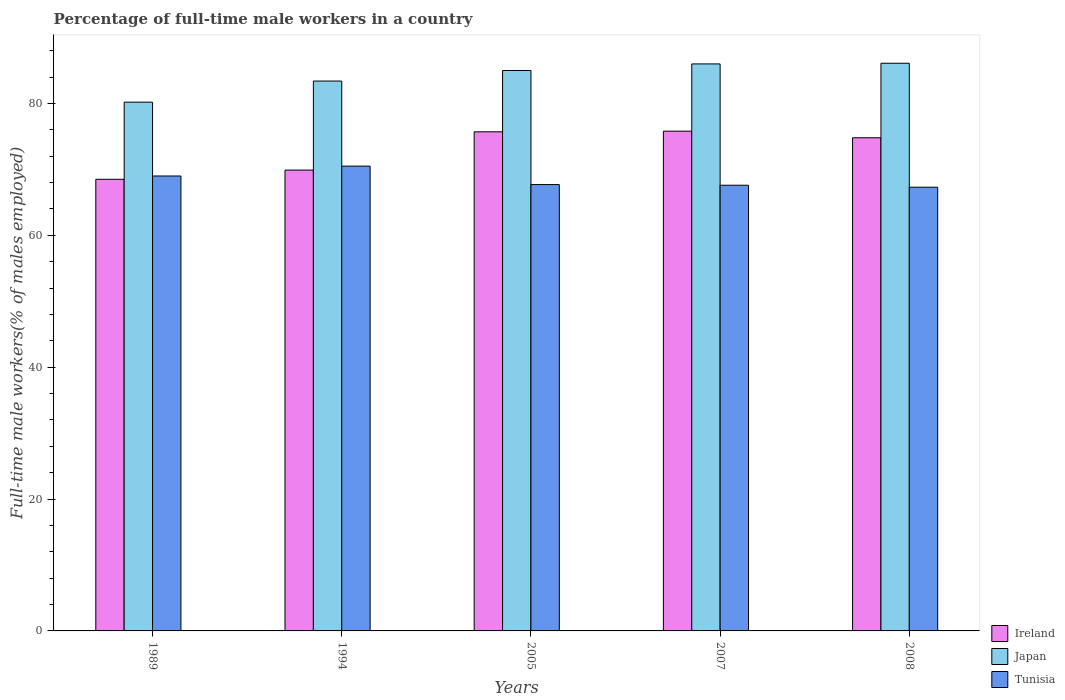Are the number of bars per tick equal to the number of legend labels?
Offer a terse response. Yes. Are the number of bars on each tick of the X-axis equal?
Give a very brief answer. Yes. How many bars are there on the 2nd tick from the left?
Your answer should be very brief. 3. What is the label of the 2nd group of bars from the left?
Offer a terse response. 1994. What is the percentage of full-time male workers in Tunisia in 2005?
Offer a very short reply. 67.7. Across all years, what is the maximum percentage of full-time male workers in Japan?
Give a very brief answer. 86.1. Across all years, what is the minimum percentage of full-time male workers in Tunisia?
Make the answer very short. 67.3. In which year was the percentage of full-time male workers in Japan minimum?
Make the answer very short. 1989. What is the total percentage of full-time male workers in Tunisia in the graph?
Provide a short and direct response. 342.1. What is the difference between the percentage of full-time male workers in Tunisia in 1989 and that in 2008?
Offer a very short reply. 1.7. What is the difference between the percentage of full-time male workers in Tunisia in 2008 and the percentage of full-time male workers in Japan in 1989?
Provide a succinct answer. -12.9. What is the average percentage of full-time male workers in Ireland per year?
Provide a short and direct response. 72.94. In the year 1989, what is the difference between the percentage of full-time male workers in Tunisia and percentage of full-time male workers in Japan?
Offer a very short reply. -11.2. What is the ratio of the percentage of full-time male workers in Tunisia in 1989 to that in 2007?
Offer a very short reply. 1.02. Is the difference between the percentage of full-time male workers in Tunisia in 1989 and 1994 greater than the difference between the percentage of full-time male workers in Japan in 1989 and 1994?
Make the answer very short. Yes. What is the difference between the highest and the lowest percentage of full-time male workers in Japan?
Ensure brevity in your answer.  5.9. In how many years, is the percentage of full-time male workers in Japan greater than the average percentage of full-time male workers in Japan taken over all years?
Ensure brevity in your answer.  3. What does the 3rd bar from the left in 2005 represents?
Your answer should be compact. Tunisia. What does the 2nd bar from the right in 1989 represents?
Provide a succinct answer. Japan. Is it the case that in every year, the sum of the percentage of full-time male workers in Ireland and percentage of full-time male workers in Japan is greater than the percentage of full-time male workers in Tunisia?
Make the answer very short. Yes. How many bars are there?
Provide a succinct answer. 15. Are all the bars in the graph horizontal?
Your answer should be very brief. No. How many years are there in the graph?
Provide a succinct answer. 5. What is the difference between two consecutive major ticks on the Y-axis?
Offer a terse response. 20. Are the values on the major ticks of Y-axis written in scientific E-notation?
Your answer should be compact. No. Does the graph contain grids?
Your answer should be compact. No. What is the title of the graph?
Your answer should be very brief. Percentage of full-time male workers in a country. What is the label or title of the Y-axis?
Offer a very short reply. Full-time male workers(% of males employed). What is the Full-time male workers(% of males employed) in Ireland in 1989?
Keep it short and to the point. 68.5. What is the Full-time male workers(% of males employed) in Japan in 1989?
Provide a succinct answer. 80.2. What is the Full-time male workers(% of males employed) in Tunisia in 1989?
Ensure brevity in your answer.  69. What is the Full-time male workers(% of males employed) of Ireland in 1994?
Offer a very short reply. 69.9. What is the Full-time male workers(% of males employed) of Japan in 1994?
Keep it short and to the point. 83.4. What is the Full-time male workers(% of males employed) in Tunisia in 1994?
Keep it short and to the point. 70.5. What is the Full-time male workers(% of males employed) of Ireland in 2005?
Provide a short and direct response. 75.7. What is the Full-time male workers(% of males employed) in Tunisia in 2005?
Your answer should be very brief. 67.7. What is the Full-time male workers(% of males employed) of Ireland in 2007?
Offer a very short reply. 75.8. What is the Full-time male workers(% of males employed) in Tunisia in 2007?
Offer a terse response. 67.6. What is the Full-time male workers(% of males employed) in Ireland in 2008?
Provide a succinct answer. 74.8. What is the Full-time male workers(% of males employed) of Japan in 2008?
Provide a short and direct response. 86.1. What is the Full-time male workers(% of males employed) of Tunisia in 2008?
Keep it short and to the point. 67.3. Across all years, what is the maximum Full-time male workers(% of males employed) in Ireland?
Provide a succinct answer. 75.8. Across all years, what is the maximum Full-time male workers(% of males employed) in Japan?
Keep it short and to the point. 86.1. Across all years, what is the maximum Full-time male workers(% of males employed) of Tunisia?
Ensure brevity in your answer.  70.5. Across all years, what is the minimum Full-time male workers(% of males employed) in Ireland?
Provide a short and direct response. 68.5. Across all years, what is the minimum Full-time male workers(% of males employed) of Japan?
Make the answer very short. 80.2. Across all years, what is the minimum Full-time male workers(% of males employed) of Tunisia?
Keep it short and to the point. 67.3. What is the total Full-time male workers(% of males employed) of Ireland in the graph?
Provide a short and direct response. 364.7. What is the total Full-time male workers(% of males employed) in Japan in the graph?
Give a very brief answer. 420.7. What is the total Full-time male workers(% of males employed) in Tunisia in the graph?
Ensure brevity in your answer.  342.1. What is the difference between the Full-time male workers(% of males employed) in Tunisia in 1989 and that in 2005?
Offer a terse response. 1.3. What is the difference between the Full-time male workers(% of males employed) in Japan in 1989 and that in 2007?
Provide a succinct answer. -5.8. What is the difference between the Full-time male workers(% of males employed) of Japan in 1989 and that in 2008?
Your answer should be very brief. -5.9. What is the difference between the Full-time male workers(% of males employed) in Tunisia in 1989 and that in 2008?
Your response must be concise. 1.7. What is the difference between the Full-time male workers(% of males employed) of Tunisia in 1994 and that in 2005?
Ensure brevity in your answer.  2.8. What is the difference between the Full-time male workers(% of males employed) in Ireland in 1994 and that in 2007?
Your response must be concise. -5.9. What is the difference between the Full-time male workers(% of males employed) of Ireland in 1994 and that in 2008?
Offer a terse response. -4.9. What is the difference between the Full-time male workers(% of males employed) of Japan in 1994 and that in 2008?
Ensure brevity in your answer.  -2.7. What is the difference between the Full-time male workers(% of males employed) in Ireland in 2005 and that in 2007?
Offer a terse response. -0.1. What is the difference between the Full-time male workers(% of males employed) in Japan in 2005 and that in 2008?
Give a very brief answer. -1.1. What is the difference between the Full-time male workers(% of males employed) of Tunisia in 2005 and that in 2008?
Make the answer very short. 0.4. What is the difference between the Full-time male workers(% of males employed) of Ireland in 2007 and that in 2008?
Your answer should be compact. 1. What is the difference between the Full-time male workers(% of males employed) in Tunisia in 2007 and that in 2008?
Offer a very short reply. 0.3. What is the difference between the Full-time male workers(% of males employed) in Ireland in 1989 and the Full-time male workers(% of males employed) in Japan in 1994?
Keep it short and to the point. -14.9. What is the difference between the Full-time male workers(% of males employed) of Ireland in 1989 and the Full-time male workers(% of males employed) of Japan in 2005?
Make the answer very short. -16.5. What is the difference between the Full-time male workers(% of males employed) of Ireland in 1989 and the Full-time male workers(% of males employed) of Tunisia in 2005?
Your answer should be compact. 0.8. What is the difference between the Full-time male workers(% of males employed) in Japan in 1989 and the Full-time male workers(% of males employed) in Tunisia in 2005?
Keep it short and to the point. 12.5. What is the difference between the Full-time male workers(% of males employed) of Ireland in 1989 and the Full-time male workers(% of males employed) of Japan in 2007?
Your answer should be very brief. -17.5. What is the difference between the Full-time male workers(% of males employed) in Ireland in 1989 and the Full-time male workers(% of males employed) in Tunisia in 2007?
Make the answer very short. 0.9. What is the difference between the Full-time male workers(% of males employed) in Ireland in 1989 and the Full-time male workers(% of males employed) in Japan in 2008?
Make the answer very short. -17.6. What is the difference between the Full-time male workers(% of males employed) in Japan in 1989 and the Full-time male workers(% of males employed) in Tunisia in 2008?
Offer a terse response. 12.9. What is the difference between the Full-time male workers(% of males employed) of Ireland in 1994 and the Full-time male workers(% of males employed) of Japan in 2005?
Keep it short and to the point. -15.1. What is the difference between the Full-time male workers(% of males employed) of Ireland in 1994 and the Full-time male workers(% of males employed) of Tunisia in 2005?
Offer a very short reply. 2.2. What is the difference between the Full-time male workers(% of males employed) in Japan in 1994 and the Full-time male workers(% of males employed) in Tunisia in 2005?
Ensure brevity in your answer.  15.7. What is the difference between the Full-time male workers(% of males employed) of Ireland in 1994 and the Full-time male workers(% of males employed) of Japan in 2007?
Your answer should be very brief. -16.1. What is the difference between the Full-time male workers(% of males employed) of Japan in 1994 and the Full-time male workers(% of males employed) of Tunisia in 2007?
Make the answer very short. 15.8. What is the difference between the Full-time male workers(% of males employed) in Ireland in 1994 and the Full-time male workers(% of males employed) in Japan in 2008?
Give a very brief answer. -16.2. What is the difference between the Full-time male workers(% of males employed) of Ireland in 1994 and the Full-time male workers(% of males employed) of Tunisia in 2008?
Keep it short and to the point. 2.6. What is the difference between the Full-time male workers(% of males employed) in Japan in 1994 and the Full-time male workers(% of males employed) in Tunisia in 2008?
Your answer should be very brief. 16.1. What is the difference between the Full-time male workers(% of males employed) of Ireland in 2005 and the Full-time male workers(% of males employed) of Japan in 2007?
Ensure brevity in your answer.  -10.3. What is the difference between the Full-time male workers(% of males employed) in Ireland in 2005 and the Full-time male workers(% of males employed) in Tunisia in 2007?
Offer a very short reply. 8.1. What is the difference between the Full-time male workers(% of males employed) in Japan in 2005 and the Full-time male workers(% of males employed) in Tunisia in 2007?
Offer a terse response. 17.4. What is the difference between the Full-time male workers(% of males employed) in Ireland in 2005 and the Full-time male workers(% of males employed) in Tunisia in 2008?
Make the answer very short. 8.4. What is the difference between the Full-time male workers(% of males employed) of Japan in 2005 and the Full-time male workers(% of males employed) of Tunisia in 2008?
Provide a succinct answer. 17.7. What is the difference between the Full-time male workers(% of males employed) of Japan in 2007 and the Full-time male workers(% of males employed) of Tunisia in 2008?
Provide a short and direct response. 18.7. What is the average Full-time male workers(% of males employed) in Ireland per year?
Keep it short and to the point. 72.94. What is the average Full-time male workers(% of males employed) of Japan per year?
Ensure brevity in your answer.  84.14. What is the average Full-time male workers(% of males employed) of Tunisia per year?
Offer a very short reply. 68.42. In the year 1989, what is the difference between the Full-time male workers(% of males employed) of Japan and Full-time male workers(% of males employed) of Tunisia?
Give a very brief answer. 11.2. In the year 1994, what is the difference between the Full-time male workers(% of males employed) of Ireland and Full-time male workers(% of males employed) of Japan?
Ensure brevity in your answer.  -13.5. In the year 2005, what is the difference between the Full-time male workers(% of males employed) of Ireland and Full-time male workers(% of males employed) of Japan?
Offer a very short reply. -9.3. In the year 2007, what is the difference between the Full-time male workers(% of males employed) of Ireland and Full-time male workers(% of males employed) of Tunisia?
Your answer should be compact. 8.2. In the year 2007, what is the difference between the Full-time male workers(% of males employed) in Japan and Full-time male workers(% of males employed) in Tunisia?
Keep it short and to the point. 18.4. What is the ratio of the Full-time male workers(% of males employed) in Japan in 1989 to that in 1994?
Your response must be concise. 0.96. What is the ratio of the Full-time male workers(% of males employed) of Tunisia in 1989 to that in 1994?
Offer a very short reply. 0.98. What is the ratio of the Full-time male workers(% of males employed) in Ireland in 1989 to that in 2005?
Make the answer very short. 0.9. What is the ratio of the Full-time male workers(% of males employed) of Japan in 1989 to that in 2005?
Provide a succinct answer. 0.94. What is the ratio of the Full-time male workers(% of males employed) in Tunisia in 1989 to that in 2005?
Your response must be concise. 1.02. What is the ratio of the Full-time male workers(% of males employed) of Ireland in 1989 to that in 2007?
Make the answer very short. 0.9. What is the ratio of the Full-time male workers(% of males employed) of Japan in 1989 to that in 2007?
Provide a short and direct response. 0.93. What is the ratio of the Full-time male workers(% of males employed) of Tunisia in 1989 to that in 2007?
Your answer should be compact. 1.02. What is the ratio of the Full-time male workers(% of males employed) of Ireland in 1989 to that in 2008?
Give a very brief answer. 0.92. What is the ratio of the Full-time male workers(% of males employed) of Japan in 1989 to that in 2008?
Your answer should be very brief. 0.93. What is the ratio of the Full-time male workers(% of males employed) in Tunisia in 1989 to that in 2008?
Ensure brevity in your answer.  1.03. What is the ratio of the Full-time male workers(% of males employed) of Ireland in 1994 to that in 2005?
Your answer should be compact. 0.92. What is the ratio of the Full-time male workers(% of males employed) in Japan in 1994 to that in 2005?
Make the answer very short. 0.98. What is the ratio of the Full-time male workers(% of males employed) of Tunisia in 1994 to that in 2005?
Offer a very short reply. 1.04. What is the ratio of the Full-time male workers(% of males employed) of Ireland in 1994 to that in 2007?
Keep it short and to the point. 0.92. What is the ratio of the Full-time male workers(% of males employed) of Japan in 1994 to that in 2007?
Give a very brief answer. 0.97. What is the ratio of the Full-time male workers(% of males employed) of Tunisia in 1994 to that in 2007?
Offer a very short reply. 1.04. What is the ratio of the Full-time male workers(% of males employed) of Ireland in 1994 to that in 2008?
Give a very brief answer. 0.93. What is the ratio of the Full-time male workers(% of males employed) in Japan in 1994 to that in 2008?
Offer a very short reply. 0.97. What is the ratio of the Full-time male workers(% of males employed) of Tunisia in 1994 to that in 2008?
Offer a terse response. 1.05. What is the ratio of the Full-time male workers(% of males employed) in Japan in 2005 to that in 2007?
Give a very brief answer. 0.99. What is the ratio of the Full-time male workers(% of males employed) in Tunisia in 2005 to that in 2007?
Offer a very short reply. 1. What is the ratio of the Full-time male workers(% of males employed) of Japan in 2005 to that in 2008?
Provide a short and direct response. 0.99. What is the ratio of the Full-time male workers(% of males employed) in Tunisia in 2005 to that in 2008?
Your response must be concise. 1.01. What is the ratio of the Full-time male workers(% of males employed) of Ireland in 2007 to that in 2008?
Provide a succinct answer. 1.01. What is the ratio of the Full-time male workers(% of males employed) of Japan in 2007 to that in 2008?
Provide a succinct answer. 1. What is the ratio of the Full-time male workers(% of males employed) of Tunisia in 2007 to that in 2008?
Offer a terse response. 1. What is the difference between the highest and the second highest Full-time male workers(% of males employed) in Ireland?
Offer a terse response. 0.1. What is the difference between the highest and the second highest Full-time male workers(% of males employed) in Tunisia?
Offer a very short reply. 1.5. What is the difference between the highest and the lowest Full-time male workers(% of males employed) of Japan?
Offer a very short reply. 5.9. 